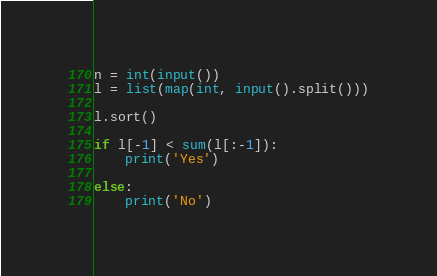<code> <loc_0><loc_0><loc_500><loc_500><_Python_>n = int(input())
l = list(map(int, input().split()))

l.sort()

if l[-1] < sum(l[:-1]):
    print('Yes')

else:
    print('No')

</code> 